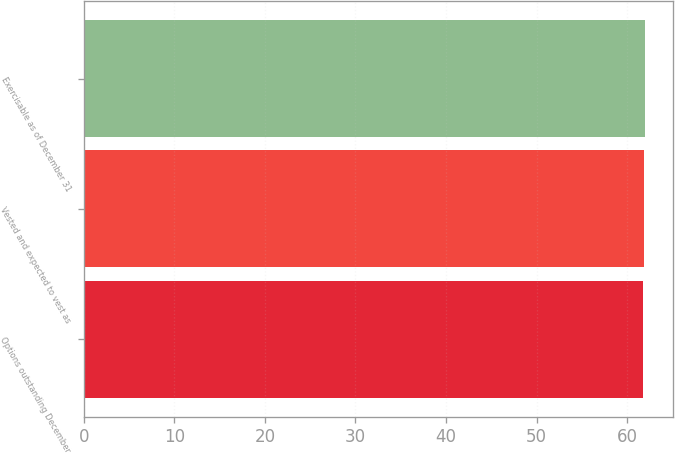Convert chart. <chart><loc_0><loc_0><loc_500><loc_500><bar_chart><fcel>Options outstanding December<fcel>Vested and expected to vest as<fcel>Exercisable as of December 31<nl><fcel>61.73<fcel>61.83<fcel>61.93<nl></chart> 